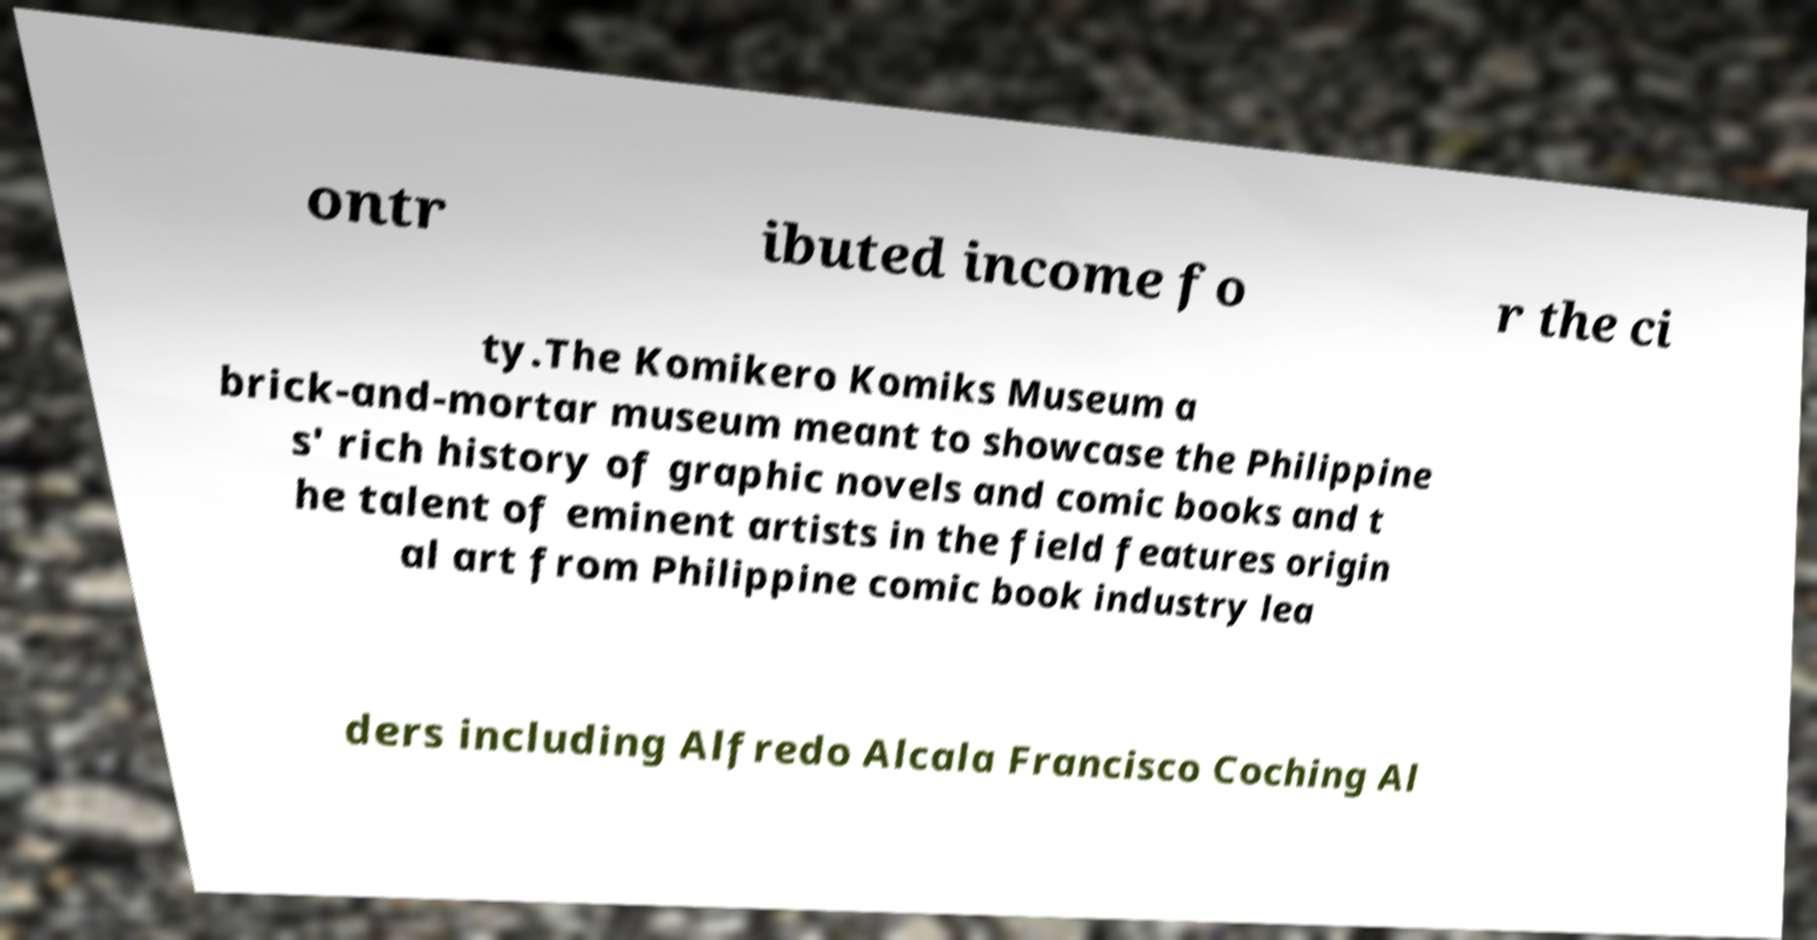For documentation purposes, I need the text within this image transcribed. Could you provide that? ontr ibuted income fo r the ci ty.The Komikero Komiks Museum a brick-and-mortar museum meant to showcase the Philippine s' rich history of graphic novels and comic books and t he talent of eminent artists in the field features origin al art from Philippine comic book industry lea ders including Alfredo Alcala Francisco Coching Al 